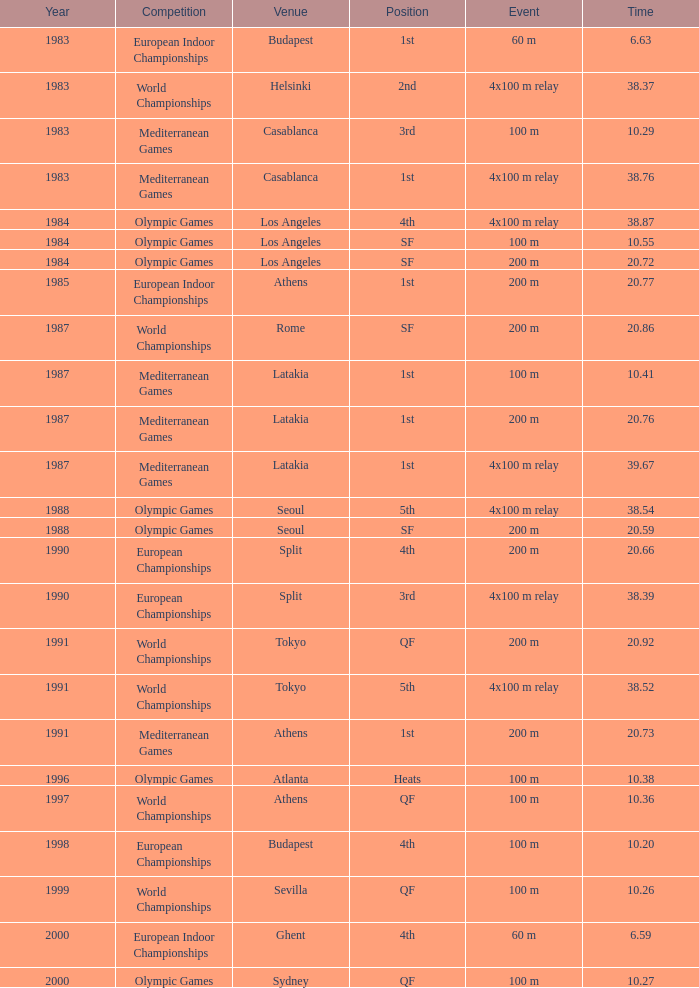What Event has a Position of 1st, a Year of 1983, and a Venue of budapest? 60 m. 